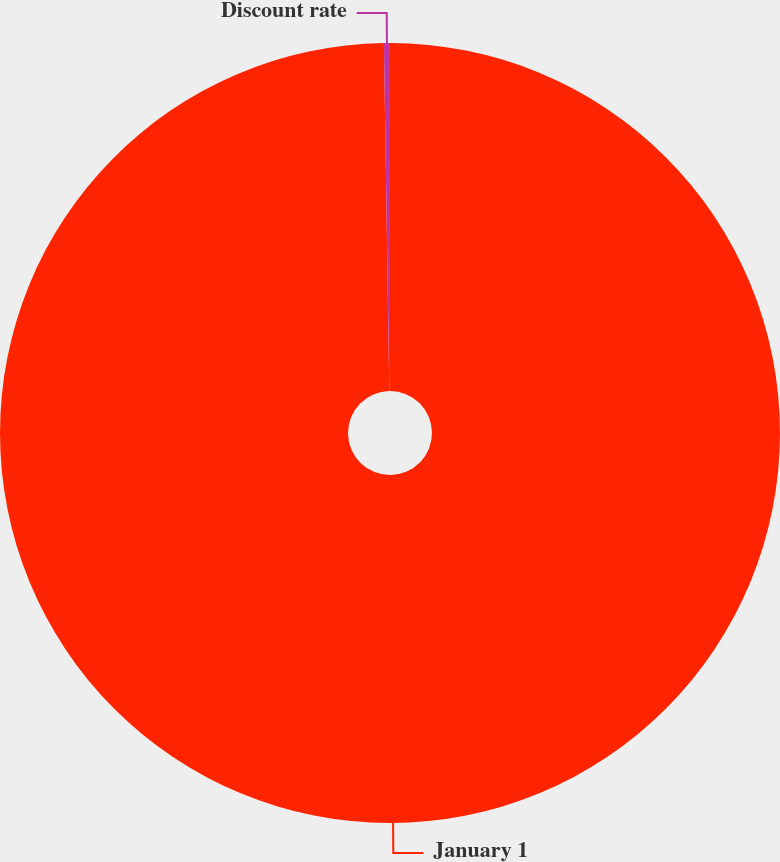<chart> <loc_0><loc_0><loc_500><loc_500><pie_chart><fcel>January 1<fcel>Discount rate<nl><fcel>99.75%<fcel>0.25%<nl></chart> 